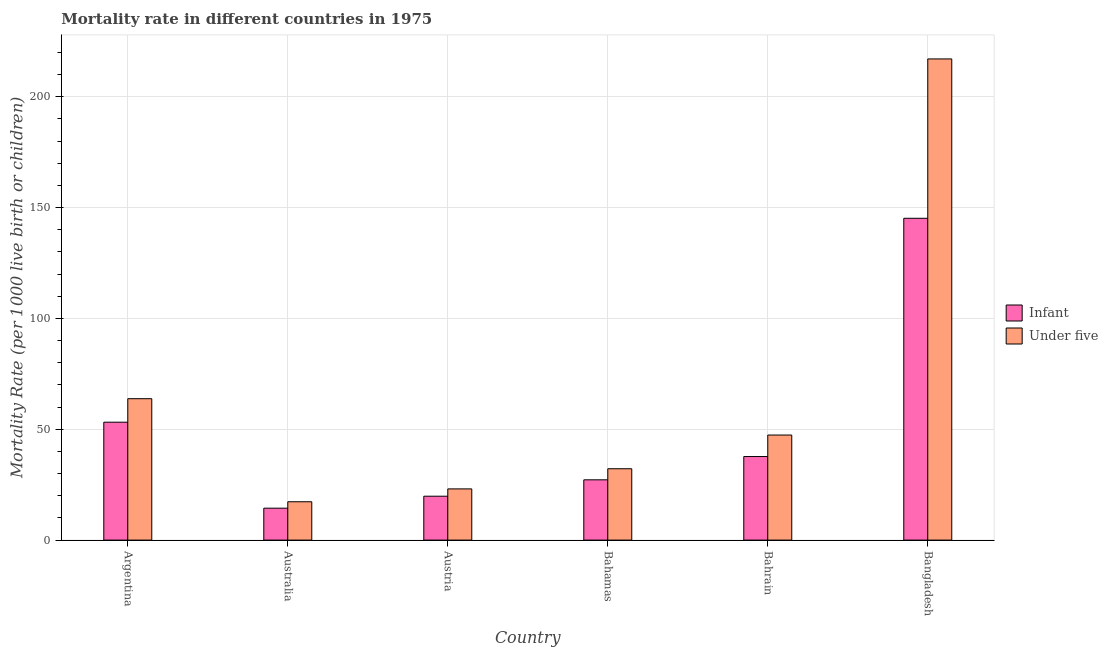How many different coloured bars are there?
Ensure brevity in your answer.  2. How many groups of bars are there?
Your answer should be very brief. 6. Are the number of bars per tick equal to the number of legend labels?
Your answer should be very brief. Yes. What is the label of the 5th group of bars from the left?
Your response must be concise. Bahrain. In how many cases, is the number of bars for a given country not equal to the number of legend labels?
Make the answer very short. 0. What is the infant mortality rate in Bangladesh?
Your answer should be compact. 145.2. Across all countries, what is the maximum infant mortality rate?
Provide a succinct answer. 145.2. What is the total under-5 mortality rate in the graph?
Offer a terse response. 400.9. What is the difference between the under-5 mortality rate in Austria and that in Bangladesh?
Offer a very short reply. -194. What is the difference between the under-5 mortality rate in Australia and the infant mortality rate in Bangladesh?
Provide a succinct answer. -127.9. What is the average under-5 mortality rate per country?
Your answer should be very brief. 66.82. What is the difference between the infant mortality rate and under-5 mortality rate in Bangladesh?
Keep it short and to the point. -71.9. In how many countries, is the under-5 mortality rate greater than 130 ?
Your response must be concise. 1. What is the ratio of the infant mortality rate in Australia to that in Bangladesh?
Offer a terse response. 0.1. Is the under-5 mortality rate in Argentina less than that in Austria?
Offer a terse response. No. What is the difference between the highest and the second highest infant mortality rate?
Give a very brief answer. 92. What is the difference between the highest and the lowest infant mortality rate?
Offer a terse response. 130.8. In how many countries, is the under-5 mortality rate greater than the average under-5 mortality rate taken over all countries?
Your answer should be very brief. 1. What does the 2nd bar from the left in Austria represents?
Your answer should be very brief. Under five. What does the 2nd bar from the right in Bahrain represents?
Offer a terse response. Infant. How many bars are there?
Give a very brief answer. 12. Are all the bars in the graph horizontal?
Keep it short and to the point. No. What is the difference between two consecutive major ticks on the Y-axis?
Provide a short and direct response. 50. Are the values on the major ticks of Y-axis written in scientific E-notation?
Offer a terse response. No. Does the graph contain any zero values?
Provide a succinct answer. No. Does the graph contain grids?
Keep it short and to the point. Yes. Where does the legend appear in the graph?
Offer a terse response. Center right. How many legend labels are there?
Keep it short and to the point. 2. What is the title of the graph?
Your response must be concise. Mortality rate in different countries in 1975. Does "Number of departures" appear as one of the legend labels in the graph?
Provide a succinct answer. No. What is the label or title of the X-axis?
Make the answer very short. Country. What is the label or title of the Y-axis?
Provide a succinct answer. Mortality Rate (per 1000 live birth or children). What is the Mortality Rate (per 1000 live birth or children) of Infant in Argentina?
Offer a terse response. 53.2. What is the Mortality Rate (per 1000 live birth or children) in Under five in Argentina?
Provide a succinct answer. 63.8. What is the Mortality Rate (per 1000 live birth or children) in Infant in Australia?
Your response must be concise. 14.4. What is the Mortality Rate (per 1000 live birth or children) of Infant in Austria?
Provide a succinct answer. 19.8. What is the Mortality Rate (per 1000 live birth or children) in Under five in Austria?
Your answer should be very brief. 23.1. What is the Mortality Rate (per 1000 live birth or children) in Infant in Bahamas?
Your answer should be compact. 27.2. What is the Mortality Rate (per 1000 live birth or children) of Under five in Bahamas?
Provide a succinct answer. 32.2. What is the Mortality Rate (per 1000 live birth or children) of Infant in Bahrain?
Your answer should be very brief. 37.7. What is the Mortality Rate (per 1000 live birth or children) of Under five in Bahrain?
Provide a short and direct response. 47.4. What is the Mortality Rate (per 1000 live birth or children) in Infant in Bangladesh?
Offer a terse response. 145.2. What is the Mortality Rate (per 1000 live birth or children) in Under five in Bangladesh?
Your response must be concise. 217.1. Across all countries, what is the maximum Mortality Rate (per 1000 live birth or children) in Infant?
Make the answer very short. 145.2. Across all countries, what is the maximum Mortality Rate (per 1000 live birth or children) in Under five?
Make the answer very short. 217.1. What is the total Mortality Rate (per 1000 live birth or children) in Infant in the graph?
Your response must be concise. 297.5. What is the total Mortality Rate (per 1000 live birth or children) in Under five in the graph?
Offer a very short reply. 400.9. What is the difference between the Mortality Rate (per 1000 live birth or children) in Infant in Argentina and that in Australia?
Your response must be concise. 38.8. What is the difference between the Mortality Rate (per 1000 live birth or children) of Under five in Argentina and that in Australia?
Ensure brevity in your answer.  46.5. What is the difference between the Mortality Rate (per 1000 live birth or children) in Infant in Argentina and that in Austria?
Ensure brevity in your answer.  33.4. What is the difference between the Mortality Rate (per 1000 live birth or children) of Under five in Argentina and that in Austria?
Offer a very short reply. 40.7. What is the difference between the Mortality Rate (per 1000 live birth or children) in Under five in Argentina and that in Bahamas?
Keep it short and to the point. 31.6. What is the difference between the Mortality Rate (per 1000 live birth or children) in Infant in Argentina and that in Bahrain?
Make the answer very short. 15.5. What is the difference between the Mortality Rate (per 1000 live birth or children) in Infant in Argentina and that in Bangladesh?
Keep it short and to the point. -92. What is the difference between the Mortality Rate (per 1000 live birth or children) in Under five in Argentina and that in Bangladesh?
Make the answer very short. -153.3. What is the difference between the Mortality Rate (per 1000 live birth or children) in Under five in Australia and that in Austria?
Give a very brief answer. -5.8. What is the difference between the Mortality Rate (per 1000 live birth or children) of Infant in Australia and that in Bahamas?
Give a very brief answer. -12.8. What is the difference between the Mortality Rate (per 1000 live birth or children) of Under five in Australia and that in Bahamas?
Give a very brief answer. -14.9. What is the difference between the Mortality Rate (per 1000 live birth or children) in Infant in Australia and that in Bahrain?
Offer a terse response. -23.3. What is the difference between the Mortality Rate (per 1000 live birth or children) of Under five in Australia and that in Bahrain?
Provide a short and direct response. -30.1. What is the difference between the Mortality Rate (per 1000 live birth or children) in Infant in Australia and that in Bangladesh?
Your answer should be very brief. -130.8. What is the difference between the Mortality Rate (per 1000 live birth or children) of Under five in Australia and that in Bangladesh?
Keep it short and to the point. -199.8. What is the difference between the Mortality Rate (per 1000 live birth or children) in Infant in Austria and that in Bahamas?
Give a very brief answer. -7.4. What is the difference between the Mortality Rate (per 1000 live birth or children) of Infant in Austria and that in Bahrain?
Provide a short and direct response. -17.9. What is the difference between the Mortality Rate (per 1000 live birth or children) in Under five in Austria and that in Bahrain?
Ensure brevity in your answer.  -24.3. What is the difference between the Mortality Rate (per 1000 live birth or children) in Infant in Austria and that in Bangladesh?
Keep it short and to the point. -125.4. What is the difference between the Mortality Rate (per 1000 live birth or children) of Under five in Austria and that in Bangladesh?
Make the answer very short. -194. What is the difference between the Mortality Rate (per 1000 live birth or children) in Infant in Bahamas and that in Bahrain?
Offer a very short reply. -10.5. What is the difference between the Mortality Rate (per 1000 live birth or children) of Under five in Bahamas and that in Bahrain?
Your answer should be very brief. -15.2. What is the difference between the Mortality Rate (per 1000 live birth or children) in Infant in Bahamas and that in Bangladesh?
Provide a succinct answer. -118. What is the difference between the Mortality Rate (per 1000 live birth or children) of Under five in Bahamas and that in Bangladesh?
Keep it short and to the point. -184.9. What is the difference between the Mortality Rate (per 1000 live birth or children) of Infant in Bahrain and that in Bangladesh?
Offer a terse response. -107.5. What is the difference between the Mortality Rate (per 1000 live birth or children) of Under five in Bahrain and that in Bangladesh?
Ensure brevity in your answer.  -169.7. What is the difference between the Mortality Rate (per 1000 live birth or children) of Infant in Argentina and the Mortality Rate (per 1000 live birth or children) of Under five in Australia?
Provide a short and direct response. 35.9. What is the difference between the Mortality Rate (per 1000 live birth or children) in Infant in Argentina and the Mortality Rate (per 1000 live birth or children) in Under five in Austria?
Keep it short and to the point. 30.1. What is the difference between the Mortality Rate (per 1000 live birth or children) of Infant in Argentina and the Mortality Rate (per 1000 live birth or children) of Under five in Bangladesh?
Ensure brevity in your answer.  -163.9. What is the difference between the Mortality Rate (per 1000 live birth or children) of Infant in Australia and the Mortality Rate (per 1000 live birth or children) of Under five in Austria?
Your response must be concise. -8.7. What is the difference between the Mortality Rate (per 1000 live birth or children) of Infant in Australia and the Mortality Rate (per 1000 live birth or children) of Under five in Bahamas?
Give a very brief answer. -17.8. What is the difference between the Mortality Rate (per 1000 live birth or children) of Infant in Australia and the Mortality Rate (per 1000 live birth or children) of Under five in Bahrain?
Offer a terse response. -33. What is the difference between the Mortality Rate (per 1000 live birth or children) in Infant in Australia and the Mortality Rate (per 1000 live birth or children) in Under five in Bangladesh?
Your response must be concise. -202.7. What is the difference between the Mortality Rate (per 1000 live birth or children) of Infant in Austria and the Mortality Rate (per 1000 live birth or children) of Under five in Bahrain?
Offer a terse response. -27.6. What is the difference between the Mortality Rate (per 1000 live birth or children) of Infant in Austria and the Mortality Rate (per 1000 live birth or children) of Under five in Bangladesh?
Provide a succinct answer. -197.3. What is the difference between the Mortality Rate (per 1000 live birth or children) of Infant in Bahamas and the Mortality Rate (per 1000 live birth or children) of Under five in Bahrain?
Make the answer very short. -20.2. What is the difference between the Mortality Rate (per 1000 live birth or children) in Infant in Bahamas and the Mortality Rate (per 1000 live birth or children) in Under five in Bangladesh?
Offer a very short reply. -189.9. What is the difference between the Mortality Rate (per 1000 live birth or children) of Infant in Bahrain and the Mortality Rate (per 1000 live birth or children) of Under five in Bangladesh?
Offer a very short reply. -179.4. What is the average Mortality Rate (per 1000 live birth or children) in Infant per country?
Your response must be concise. 49.58. What is the average Mortality Rate (per 1000 live birth or children) of Under five per country?
Make the answer very short. 66.82. What is the difference between the Mortality Rate (per 1000 live birth or children) of Infant and Mortality Rate (per 1000 live birth or children) of Under five in Argentina?
Offer a terse response. -10.6. What is the difference between the Mortality Rate (per 1000 live birth or children) of Infant and Mortality Rate (per 1000 live birth or children) of Under five in Bahrain?
Your response must be concise. -9.7. What is the difference between the Mortality Rate (per 1000 live birth or children) of Infant and Mortality Rate (per 1000 live birth or children) of Under five in Bangladesh?
Make the answer very short. -71.9. What is the ratio of the Mortality Rate (per 1000 live birth or children) in Infant in Argentina to that in Australia?
Your response must be concise. 3.69. What is the ratio of the Mortality Rate (per 1000 live birth or children) in Under five in Argentina to that in Australia?
Offer a very short reply. 3.69. What is the ratio of the Mortality Rate (per 1000 live birth or children) of Infant in Argentina to that in Austria?
Provide a short and direct response. 2.69. What is the ratio of the Mortality Rate (per 1000 live birth or children) in Under five in Argentina to that in Austria?
Provide a succinct answer. 2.76. What is the ratio of the Mortality Rate (per 1000 live birth or children) in Infant in Argentina to that in Bahamas?
Offer a very short reply. 1.96. What is the ratio of the Mortality Rate (per 1000 live birth or children) of Under five in Argentina to that in Bahamas?
Give a very brief answer. 1.98. What is the ratio of the Mortality Rate (per 1000 live birth or children) of Infant in Argentina to that in Bahrain?
Make the answer very short. 1.41. What is the ratio of the Mortality Rate (per 1000 live birth or children) of Under five in Argentina to that in Bahrain?
Offer a terse response. 1.35. What is the ratio of the Mortality Rate (per 1000 live birth or children) in Infant in Argentina to that in Bangladesh?
Ensure brevity in your answer.  0.37. What is the ratio of the Mortality Rate (per 1000 live birth or children) of Under five in Argentina to that in Bangladesh?
Offer a very short reply. 0.29. What is the ratio of the Mortality Rate (per 1000 live birth or children) of Infant in Australia to that in Austria?
Give a very brief answer. 0.73. What is the ratio of the Mortality Rate (per 1000 live birth or children) of Under five in Australia to that in Austria?
Make the answer very short. 0.75. What is the ratio of the Mortality Rate (per 1000 live birth or children) of Infant in Australia to that in Bahamas?
Offer a terse response. 0.53. What is the ratio of the Mortality Rate (per 1000 live birth or children) in Under five in Australia to that in Bahamas?
Offer a very short reply. 0.54. What is the ratio of the Mortality Rate (per 1000 live birth or children) in Infant in Australia to that in Bahrain?
Make the answer very short. 0.38. What is the ratio of the Mortality Rate (per 1000 live birth or children) of Under five in Australia to that in Bahrain?
Your answer should be very brief. 0.36. What is the ratio of the Mortality Rate (per 1000 live birth or children) of Infant in Australia to that in Bangladesh?
Your answer should be very brief. 0.1. What is the ratio of the Mortality Rate (per 1000 live birth or children) in Under five in Australia to that in Bangladesh?
Make the answer very short. 0.08. What is the ratio of the Mortality Rate (per 1000 live birth or children) of Infant in Austria to that in Bahamas?
Ensure brevity in your answer.  0.73. What is the ratio of the Mortality Rate (per 1000 live birth or children) in Under five in Austria to that in Bahamas?
Your answer should be compact. 0.72. What is the ratio of the Mortality Rate (per 1000 live birth or children) of Infant in Austria to that in Bahrain?
Keep it short and to the point. 0.53. What is the ratio of the Mortality Rate (per 1000 live birth or children) in Under five in Austria to that in Bahrain?
Ensure brevity in your answer.  0.49. What is the ratio of the Mortality Rate (per 1000 live birth or children) in Infant in Austria to that in Bangladesh?
Provide a succinct answer. 0.14. What is the ratio of the Mortality Rate (per 1000 live birth or children) in Under five in Austria to that in Bangladesh?
Keep it short and to the point. 0.11. What is the ratio of the Mortality Rate (per 1000 live birth or children) in Infant in Bahamas to that in Bahrain?
Make the answer very short. 0.72. What is the ratio of the Mortality Rate (per 1000 live birth or children) of Under five in Bahamas to that in Bahrain?
Give a very brief answer. 0.68. What is the ratio of the Mortality Rate (per 1000 live birth or children) in Infant in Bahamas to that in Bangladesh?
Your answer should be very brief. 0.19. What is the ratio of the Mortality Rate (per 1000 live birth or children) in Under five in Bahamas to that in Bangladesh?
Provide a succinct answer. 0.15. What is the ratio of the Mortality Rate (per 1000 live birth or children) in Infant in Bahrain to that in Bangladesh?
Keep it short and to the point. 0.26. What is the ratio of the Mortality Rate (per 1000 live birth or children) in Under five in Bahrain to that in Bangladesh?
Your response must be concise. 0.22. What is the difference between the highest and the second highest Mortality Rate (per 1000 live birth or children) of Infant?
Keep it short and to the point. 92. What is the difference between the highest and the second highest Mortality Rate (per 1000 live birth or children) in Under five?
Offer a terse response. 153.3. What is the difference between the highest and the lowest Mortality Rate (per 1000 live birth or children) in Infant?
Your response must be concise. 130.8. What is the difference between the highest and the lowest Mortality Rate (per 1000 live birth or children) in Under five?
Offer a very short reply. 199.8. 